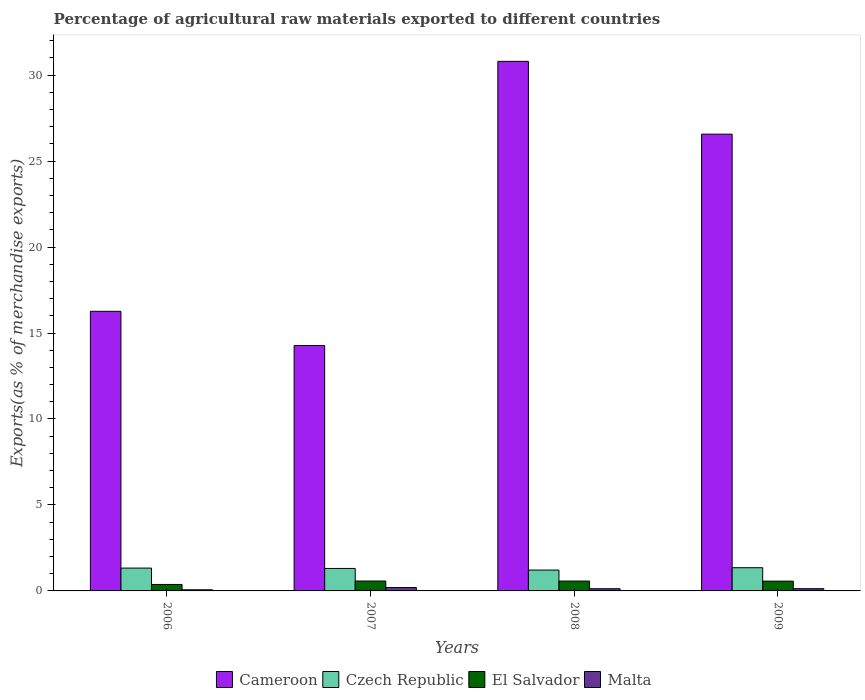How many different coloured bars are there?
Your answer should be very brief. 4. How many groups of bars are there?
Provide a succinct answer. 4. Are the number of bars on each tick of the X-axis equal?
Provide a short and direct response. Yes. How many bars are there on the 2nd tick from the left?
Offer a very short reply. 4. What is the label of the 4th group of bars from the left?
Make the answer very short. 2009. What is the percentage of exports to different countries in Cameroon in 2006?
Make the answer very short. 16.26. Across all years, what is the maximum percentage of exports to different countries in Czech Republic?
Give a very brief answer. 1.35. Across all years, what is the minimum percentage of exports to different countries in Malta?
Provide a short and direct response. 0.07. In which year was the percentage of exports to different countries in Cameroon maximum?
Make the answer very short. 2008. In which year was the percentage of exports to different countries in Cameroon minimum?
Your answer should be very brief. 2007. What is the total percentage of exports to different countries in El Salvador in the graph?
Your answer should be very brief. 2.1. What is the difference between the percentage of exports to different countries in Czech Republic in 2006 and that in 2007?
Your response must be concise. 0.02. What is the difference between the percentage of exports to different countries in Cameroon in 2008 and the percentage of exports to different countries in El Salvador in 2006?
Give a very brief answer. 30.42. What is the average percentage of exports to different countries in Malta per year?
Offer a terse response. 0.13. In the year 2009, what is the difference between the percentage of exports to different countries in Cameroon and percentage of exports to different countries in Malta?
Ensure brevity in your answer.  26.43. What is the ratio of the percentage of exports to different countries in Malta in 2007 to that in 2008?
Your answer should be very brief. 1.54. Is the percentage of exports to different countries in El Salvador in 2007 less than that in 2008?
Provide a succinct answer. No. What is the difference between the highest and the second highest percentage of exports to different countries in El Salvador?
Ensure brevity in your answer.  0. What is the difference between the highest and the lowest percentage of exports to different countries in Czech Republic?
Your answer should be compact. 0.14. In how many years, is the percentage of exports to different countries in Cameroon greater than the average percentage of exports to different countries in Cameroon taken over all years?
Give a very brief answer. 2. Is the sum of the percentage of exports to different countries in Cameroon in 2006 and 2009 greater than the maximum percentage of exports to different countries in El Salvador across all years?
Provide a succinct answer. Yes. Is it the case that in every year, the sum of the percentage of exports to different countries in Malta and percentage of exports to different countries in El Salvador is greater than the sum of percentage of exports to different countries in Cameroon and percentage of exports to different countries in Czech Republic?
Give a very brief answer. Yes. What does the 3rd bar from the left in 2009 represents?
Give a very brief answer. El Salvador. What does the 1st bar from the right in 2008 represents?
Offer a terse response. Malta. Is it the case that in every year, the sum of the percentage of exports to different countries in El Salvador and percentage of exports to different countries in Malta is greater than the percentage of exports to different countries in Czech Republic?
Provide a short and direct response. No. Are all the bars in the graph horizontal?
Your answer should be compact. No. How are the legend labels stacked?
Your response must be concise. Horizontal. What is the title of the graph?
Provide a succinct answer. Percentage of agricultural raw materials exported to different countries. What is the label or title of the Y-axis?
Your response must be concise. Exports(as % of merchandise exports). What is the Exports(as % of merchandise exports) in Cameroon in 2006?
Provide a succinct answer. 16.26. What is the Exports(as % of merchandise exports) in Czech Republic in 2006?
Ensure brevity in your answer.  1.33. What is the Exports(as % of merchandise exports) of El Salvador in 2006?
Your answer should be very brief. 0.38. What is the Exports(as % of merchandise exports) of Malta in 2006?
Make the answer very short. 0.07. What is the Exports(as % of merchandise exports) of Cameroon in 2007?
Keep it short and to the point. 14.27. What is the Exports(as % of merchandise exports) in Czech Republic in 2007?
Keep it short and to the point. 1.31. What is the Exports(as % of merchandise exports) in El Salvador in 2007?
Offer a terse response. 0.58. What is the Exports(as % of merchandise exports) in Malta in 2007?
Provide a succinct answer. 0.2. What is the Exports(as % of merchandise exports) of Cameroon in 2008?
Offer a terse response. 30.8. What is the Exports(as % of merchandise exports) of Czech Republic in 2008?
Offer a very short reply. 1.21. What is the Exports(as % of merchandise exports) of El Salvador in 2008?
Ensure brevity in your answer.  0.57. What is the Exports(as % of merchandise exports) of Malta in 2008?
Give a very brief answer. 0.13. What is the Exports(as % of merchandise exports) of Cameroon in 2009?
Provide a short and direct response. 26.57. What is the Exports(as % of merchandise exports) of Czech Republic in 2009?
Make the answer very short. 1.35. What is the Exports(as % of merchandise exports) of El Salvador in 2009?
Ensure brevity in your answer.  0.57. What is the Exports(as % of merchandise exports) in Malta in 2009?
Your answer should be compact. 0.13. Across all years, what is the maximum Exports(as % of merchandise exports) of Cameroon?
Provide a succinct answer. 30.8. Across all years, what is the maximum Exports(as % of merchandise exports) in Czech Republic?
Your answer should be very brief. 1.35. Across all years, what is the maximum Exports(as % of merchandise exports) of El Salvador?
Offer a terse response. 0.58. Across all years, what is the maximum Exports(as % of merchandise exports) in Malta?
Give a very brief answer. 0.2. Across all years, what is the minimum Exports(as % of merchandise exports) in Cameroon?
Keep it short and to the point. 14.27. Across all years, what is the minimum Exports(as % of merchandise exports) in Czech Republic?
Your answer should be compact. 1.21. Across all years, what is the minimum Exports(as % of merchandise exports) of El Salvador?
Offer a very short reply. 0.38. Across all years, what is the minimum Exports(as % of merchandise exports) of Malta?
Ensure brevity in your answer.  0.07. What is the total Exports(as % of merchandise exports) of Cameroon in the graph?
Make the answer very short. 87.9. What is the total Exports(as % of merchandise exports) of Czech Republic in the graph?
Offer a very short reply. 5.2. What is the total Exports(as % of merchandise exports) of El Salvador in the graph?
Your answer should be very brief. 2.1. What is the total Exports(as % of merchandise exports) in Malta in the graph?
Offer a terse response. 0.52. What is the difference between the Exports(as % of merchandise exports) in Cameroon in 2006 and that in 2007?
Your response must be concise. 1.99. What is the difference between the Exports(as % of merchandise exports) in Czech Republic in 2006 and that in 2007?
Give a very brief answer. 0.02. What is the difference between the Exports(as % of merchandise exports) in El Salvador in 2006 and that in 2007?
Your answer should be compact. -0.2. What is the difference between the Exports(as % of merchandise exports) of Malta in 2006 and that in 2007?
Offer a terse response. -0.13. What is the difference between the Exports(as % of merchandise exports) in Cameroon in 2006 and that in 2008?
Your response must be concise. -14.54. What is the difference between the Exports(as % of merchandise exports) of Czech Republic in 2006 and that in 2008?
Your response must be concise. 0.12. What is the difference between the Exports(as % of merchandise exports) of El Salvador in 2006 and that in 2008?
Offer a terse response. -0.2. What is the difference between the Exports(as % of merchandise exports) of Malta in 2006 and that in 2008?
Ensure brevity in your answer.  -0.06. What is the difference between the Exports(as % of merchandise exports) in Cameroon in 2006 and that in 2009?
Give a very brief answer. -10.3. What is the difference between the Exports(as % of merchandise exports) in Czech Republic in 2006 and that in 2009?
Make the answer very short. -0.02. What is the difference between the Exports(as % of merchandise exports) in El Salvador in 2006 and that in 2009?
Keep it short and to the point. -0.19. What is the difference between the Exports(as % of merchandise exports) of Malta in 2006 and that in 2009?
Your response must be concise. -0.06. What is the difference between the Exports(as % of merchandise exports) of Cameroon in 2007 and that in 2008?
Offer a terse response. -16.53. What is the difference between the Exports(as % of merchandise exports) in Czech Republic in 2007 and that in 2008?
Offer a terse response. 0.1. What is the difference between the Exports(as % of merchandise exports) of El Salvador in 2007 and that in 2008?
Offer a terse response. 0. What is the difference between the Exports(as % of merchandise exports) in Malta in 2007 and that in 2008?
Offer a terse response. 0.07. What is the difference between the Exports(as % of merchandise exports) in Cameroon in 2007 and that in 2009?
Offer a terse response. -12.29. What is the difference between the Exports(as % of merchandise exports) of Czech Republic in 2007 and that in 2009?
Offer a terse response. -0.04. What is the difference between the Exports(as % of merchandise exports) in El Salvador in 2007 and that in 2009?
Keep it short and to the point. 0.01. What is the difference between the Exports(as % of merchandise exports) in Malta in 2007 and that in 2009?
Your answer should be compact. 0.07. What is the difference between the Exports(as % of merchandise exports) of Cameroon in 2008 and that in 2009?
Keep it short and to the point. 4.23. What is the difference between the Exports(as % of merchandise exports) in Czech Republic in 2008 and that in 2009?
Offer a very short reply. -0.14. What is the difference between the Exports(as % of merchandise exports) of El Salvador in 2008 and that in 2009?
Your answer should be compact. 0. What is the difference between the Exports(as % of merchandise exports) of Malta in 2008 and that in 2009?
Keep it short and to the point. -0. What is the difference between the Exports(as % of merchandise exports) in Cameroon in 2006 and the Exports(as % of merchandise exports) in Czech Republic in 2007?
Provide a short and direct response. 14.95. What is the difference between the Exports(as % of merchandise exports) in Cameroon in 2006 and the Exports(as % of merchandise exports) in El Salvador in 2007?
Offer a terse response. 15.69. What is the difference between the Exports(as % of merchandise exports) in Cameroon in 2006 and the Exports(as % of merchandise exports) in Malta in 2007?
Keep it short and to the point. 16.07. What is the difference between the Exports(as % of merchandise exports) of Czech Republic in 2006 and the Exports(as % of merchandise exports) of El Salvador in 2007?
Your response must be concise. 0.75. What is the difference between the Exports(as % of merchandise exports) of Czech Republic in 2006 and the Exports(as % of merchandise exports) of Malta in 2007?
Give a very brief answer. 1.13. What is the difference between the Exports(as % of merchandise exports) in El Salvador in 2006 and the Exports(as % of merchandise exports) in Malta in 2007?
Keep it short and to the point. 0.18. What is the difference between the Exports(as % of merchandise exports) in Cameroon in 2006 and the Exports(as % of merchandise exports) in Czech Republic in 2008?
Your response must be concise. 15.05. What is the difference between the Exports(as % of merchandise exports) in Cameroon in 2006 and the Exports(as % of merchandise exports) in El Salvador in 2008?
Provide a succinct answer. 15.69. What is the difference between the Exports(as % of merchandise exports) of Cameroon in 2006 and the Exports(as % of merchandise exports) of Malta in 2008?
Keep it short and to the point. 16.13. What is the difference between the Exports(as % of merchandise exports) in Czech Republic in 2006 and the Exports(as % of merchandise exports) in El Salvador in 2008?
Offer a terse response. 0.75. What is the difference between the Exports(as % of merchandise exports) in Czech Republic in 2006 and the Exports(as % of merchandise exports) in Malta in 2008?
Keep it short and to the point. 1.2. What is the difference between the Exports(as % of merchandise exports) in El Salvador in 2006 and the Exports(as % of merchandise exports) in Malta in 2008?
Your response must be concise. 0.25. What is the difference between the Exports(as % of merchandise exports) of Cameroon in 2006 and the Exports(as % of merchandise exports) of Czech Republic in 2009?
Provide a succinct answer. 14.91. What is the difference between the Exports(as % of merchandise exports) of Cameroon in 2006 and the Exports(as % of merchandise exports) of El Salvador in 2009?
Your response must be concise. 15.69. What is the difference between the Exports(as % of merchandise exports) in Cameroon in 2006 and the Exports(as % of merchandise exports) in Malta in 2009?
Give a very brief answer. 16.13. What is the difference between the Exports(as % of merchandise exports) of Czech Republic in 2006 and the Exports(as % of merchandise exports) of El Salvador in 2009?
Give a very brief answer. 0.76. What is the difference between the Exports(as % of merchandise exports) of Czech Republic in 2006 and the Exports(as % of merchandise exports) of Malta in 2009?
Your answer should be very brief. 1.2. What is the difference between the Exports(as % of merchandise exports) in El Salvador in 2006 and the Exports(as % of merchandise exports) in Malta in 2009?
Provide a short and direct response. 0.25. What is the difference between the Exports(as % of merchandise exports) in Cameroon in 2007 and the Exports(as % of merchandise exports) in Czech Republic in 2008?
Your response must be concise. 13.06. What is the difference between the Exports(as % of merchandise exports) in Cameroon in 2007 and the Exports(as % of merchandise exports) in El Salvador in 2008?
Provide a short and direct response. 13.7. What is the difference between the Exports(as % of merchandise exports) in Cameroon in 2007 and the Exports(as % of merchandise exports) in Malta in 2008?
Offer a terse response. 14.14. What is the difference between the Exports(as % of merchandise exports) of Czech Republic in 2007 and the Exports(as % of merchandise exports) of El Salvador in 2008?
Keep it short and to the point. 0.73. What is the difference between the Exports(as % of merchandise exports) of Czech Republic in 2007 and the Exports(as % of merchandise exports) of Malta in 2008?
Your answer should be compact. 1.18. What is the difference between the Exports(as % of merchandise exports) in El Salvador in 2007 and the Exports(as % of merchandise exports) in Malta in 2008?
Offer a terse response. 0.45. What is the difference between the Exports(as % of merchandise exports) of Cameroon in 2007 and the Exports(as % of merchandise exports) of Czech Republic in 2009?
Offer a terse response. 12.92. What is the difference between the Exports(as % of merchandise exports) in Cameroon in 2007 and the Exports(as % of merchandise exports) in El Salvador in 2009?
Offer a very short reply. 13.7. What is the difference between the Exports(as % of merchandise exports) of Cameroon in 2007 and the Exports(as % of merchandise exports) of Malta in 2009?
Provide a succinct answer. 14.14. What is the difference between the Exports(as % of merchandise exports) in Czech Republic in 2007 and the Exports(as % of merchandise exports) in El Salvador in 2009?
Offer a very short reply. 0.74. What is the difference between the Exports(as % of merchandise exports) of Czech Republic in 2007 and the Exports(as % of merchandise exports) of Malta in 2009?
Give a very brief answer. 1.18. What is the difference between the Exports(as % of merchandise exports) of El Salvador in 2007 and the Exports(as % of merchandise exports) of Malta in 2009?
Make the answer very short. 0.45. What is the difference between the Exports(as % of merchandise exports) in Cameroon in 2008 and the Exports(as % of merchandise exports) in Czech Republic in 2009?
Provide a short and direct response. 29.45. What is the difference between the Exports(as % of merchandise exports) of Cameroon in 2008 and the Exports(as % of merchandise exports) of El Salvador in 2009?
Keep it short and to the point. 30.23. What is the difference between the Exports(as % of merchandise exports) of Cameroon in 2008 and the Exports(as % of merchandise exports) of Malta in 2009?
Offer a very short reply. 30.67. What is the difference between the Exports(as % of merchandise exports) of Czech Republic in 2008 and the Exports(as % of merchandise exports) of El Salvador in 2009?
Your answer should be very brief. 0.64. What is the difference between the Exports(as % of merchandise exports) in Czech Republic in 2008 and the Exports(as % of merchandise exports) in Malta in 2009?
Keep it short and to the point. 1.08. What is the difference between the Exports(as % of merchandise exports) in El Salvador in 2008 and the Exports(as % of merchandise exports) in Malta in 2009?
Ensure brevity in your answer.  0.44. What is the average Exports(as % of merchandise exports) in Cameroon per year?
Offer a terse response. 21.97. What is the average Exports(as % of merchandise exports) of Czech Republic per year?
Make the answer very short. 1.3. What is the average Exports(as % of merchandise exports) of El Salvador per year?
Your answer should be compact. 0.52. What is the average Exports(as % of merchandise exports) in Malta per year?
Provide a succinct answer. 0.13. In the year 2006, what is the difference between the Exports(as % of merchandise exports) of Cameroon and Exports(as % of merchandise exports) of Czech Republic?
Offer a terse response. 14.93. In the year 2006, what is the difference between the Exports(as % of merchandise exports) of Cameroon and Exports(as % of merchandise exports) of El Salvador?
Your answer should be very brief. 15.89. In the year 2006, what is the difference between the Exports(as % of merchandise exports) in Cameroon and Exports(as % of merchandise exports) in Malta?
Your answer should be very brief. 16.2. In the year 2006, what is the difference between the Exports(as % of merchandise exports) of Czech Republic and Exports(as % of merchandise exports) of El Salvador?
Ensure brevity in your answer.  0.95. In the year 2006, what is the difference between the Exports(as % of merchandise exports) of Czech Republic and Exports(as % of merchandise exports) of Malta?
Provide a short and direct response. 1.26. In the year 2006, what is the difference between the Exports(as % of merchandise exports) of El Salvador and Exports(as % of merchandise exports) of Malta?
Your response must be concise. 0.31. In the year 2007, what is the difference between the Exports(as % of merchandise exports) in Cameroon and Exports(as % of merchandise exports) in Czech Republic?
Your answer should be compact. 12.96. In the year 2007, what is the difference between the Exports(as % of merchandise exports) in Cameroon and Exports(as % of merchandise exports) in El Salvador?
Keep it short and to the point. 13.7. In the year 2007, what is the difference between the Exports(as % of merchandise exports) of Cameroon and Exports(as % of merchandise exports) of Malta?
Offer a terse response. 14.08. In the year 2007, what is the difference between the Exports(as % of merchandise exports) of Czech Republic and Exports(as % of merchandise exports) of El Salvador?
Your answer should be compact. 0.73. In the year 2007, what is the difference between the Exports(as % of merchandise exports) of Czech Republic and Exports(as % of merchandise exports) of Malta?
Give a very brief answer. 1.11. In the year 2007, what is the difference between the Exports(as % of merchandise exports) in El Salvador and Exports(as % of merchandise exports) in Malta?
Keep it short and to the point. 0.38. In the year 2008, what is the difference between the Exports(as % of merchandise exports) of Cameroon and Exports(as % of merchandise exports) of Czech Republic?
Give a very brief answer. 29.59. In the year 2008, what is the difference between the Exports(as % of merchandise exports) of Cameroon and Exports(as % of merchandise exports) of El Salvador?
Offer a very short reply. 30.23. In the year 2008, what is the difference between the Exports(as % of merchandise exports) in Cameroon and Exports(as % of merchandise exports) in Malta?
Make the answer very short. 30.67. In the year 2008, what is the difference between the Exports(as % of merchandise exports) of Czech Republic and Exports(as % of merchandise exports) of El Salvador?
Your answer should be very brief. 0.64. In the year 2008, what is the difference between the Exports(as % of merchandise exports) in Czech Republic and Exports(as % of merchandise exports) in Malta?
Keep it short and to the point. 1.08. In the year 2008, what is the difference between the Exports(as % of merchandise exports) of El Salvador and Exports(as % of merchandise exports) of Malta?
Offer a terse response. 0.45. In the year 2009, what is the difference between the Exports(as % of merchandise exports) in Cameroon and Exports(as % of merchandise exports) in Czech Republic?
Your answer should be very brief. 25.21. In the year 2009, what is the difference between the Exports(as % of merchandise exports) of Cameroon and Exports(as % of merchandise exports) of El Salvador?
Your response must be concise. 26. In the year 2009, what is the difference between the Exports(as % of merchandise exports) in Cameroon and Exports(as % of merchandise exports) in Malta?
Give a very brief answer. 26.43. In the year 2009, what is the difference between the Exports(as % of merchandise exports) of Czech Republic and Exports(as % of merchandise exports) of El Salvador?
Your answer should be compact. 0.78. In the year 2009, what is the difference between the Exports(as % of merchandise exports) of Czech Republic and Exports(as % of merchandise exports) of Malta?
Provide a short and direct response. 1.22. In the year 2009, what is the difference between the Exports(as % of merchandise exports) of El Salvador and Exports(as % of merchandise exports) of Malta?
Keep it short and to the point. 0.44. What is the ratio of the Exports(as % of merchandise exports) in Cameroon in 2006 to that in 2007?
Your answer should be very brief. 1.14. What is the ratio of the Exports(as % of merchandise exports) in Czech Republic in 2006 to that in 2007?
Make the answer very short. 1.02. What is the ratio of the Exports(as % of merchandise exports) of El Salvador in 2006 to that in 2007?
Ensure brevity in your answer.  0.65. What is the ratio of the Exports(as % of merchandise exports) of Malta in 2006 to that in 2007?
Make the answer very short. 0.34. What is the ratio of the Exports(as % of merchandise exports) in Cameroon in 2006 to that in 2008?
Provide a succinct answer. 0.53. What is the ratio of the Exports(as % of merchandise exports) in Czech Republic in 2006 to that in 2008?
Ensure brevity in your answer.  1.1. What is the ratio of the Exports(as % of merchandise exports) of El Salvador in 2006 to that in 2008?
Your response must be concise. 0.66. What is the ratio of the Exports(as % of merchandise exports) of Malta in 2006 to that in 2008?
Keep it short and to the point. 0.52. What is the ratio of the Exports(as % of merchandise exports) in Cameroon in 2006 to that in 2009?
Make the answer very short. 0.61. What is the ratio of the Exports(as % of merchandise exports) of Czech Republic in 2006 to that in 2009?
Offer a very short reply. 0.98. What is the ratio of the Exports(as % of merchandise exports) of El Salvador in 2006 to that in 2009?
Your answer should be very brief. 0.66. What is the ratio of the Exports(as % of merchandise exports) of Malta in 2006 to that in 2009?
Offer a very short reply. 0.51. What is the ratio of the Exports(as % of merchandise exports) in Cameroon in 2007 to that in 2008?
Make the answer very short. 0.46. What is the ratio of the Exports(as % of merchandise exports) of Czech Republic in 2007 to that in 2008?
Ensure brevity in your answer.  1.08. What is the ratio of the Exports(as % of merchandise exports) in El Salvador in 2007 to that in 2008?
Your answer should be very brief. 1. What is the ratio of the Exports(as % of merchandise exports) in Malta in 2007 to that in 2008?
Offer a very short reply. 1.54. What is the ratio of the Exports(as % of merchandise exports) of Cameroon in 2007 to that in 2009?
Provide a succinct answer. 0.54. What is the ratio of the Exports(as % of merchandise exports) in Czech Republic in 2007 to that in 2009?
Your response must be concise. 0.97. What is the ratio of the Exports(as % of merchandise exports) of El Salvador in 2007 to that in 2009?
Give a very brief answer. 1.01. What is the ratio of the Exports(as % of merchandise exports) in Malta in 2007 to that in 2009?
Your answer should be very brief. 1.5. What is the ratio of the Exports(as % of merchandise exports) in Cameroon in 2008 to that in 2009?
Your response must be concise. 1.16. What is the ratio of the Exports(as % of merchandise exports) in Czech Republic in 2008 to that in 2009?
Offer a terse response. 0.9. What is the ratio of the Exports(as % of merchandise exports) in El Salvador in 2008 to that in 2009?
Your response must be concise. 1.01. What is the ratio of the Exports(as % of merchandise exports) of Malta in 2008 to that in 2009?
Keep it short and to the point. 0.98. What is the difference between the highest and the second highest Exports(as % of merchandise exports) in Cameroon?
Your answer should be very brief. 4.23. What is the difference between the highest and the second highest Exports(as % of merchandise exports) of Czech Republic?
Your answer should be compact. 0.02. What is the difference between the highest and the second highest Exports(as % of merchandise exports) in El Salvador?
Provide a succinct answer. 0. What is the difference between the highest and the second highest Exports(as % of merchandise exports) in Malta?
Give a very brief answer. 0.07. What is the difference between the highest and the lowest Exports(as % of merchandise exports) in Cameroon?
Provide a succinct answer. 16.53. What is the difference between the highest and the lowest Exports(as % of merchandise exports) in Czech Republic?
Keep it short and to the point. 0.14. What is the difference between the highest and the lowest Exports(as % of merchandise exports) of El Salvador?
Ensure brevity in your answer.  0.2. What is the difference between the highest and the lowest Exports(as % of merchandise exports) in Malta?
Your answer should be compact. 0.13. 